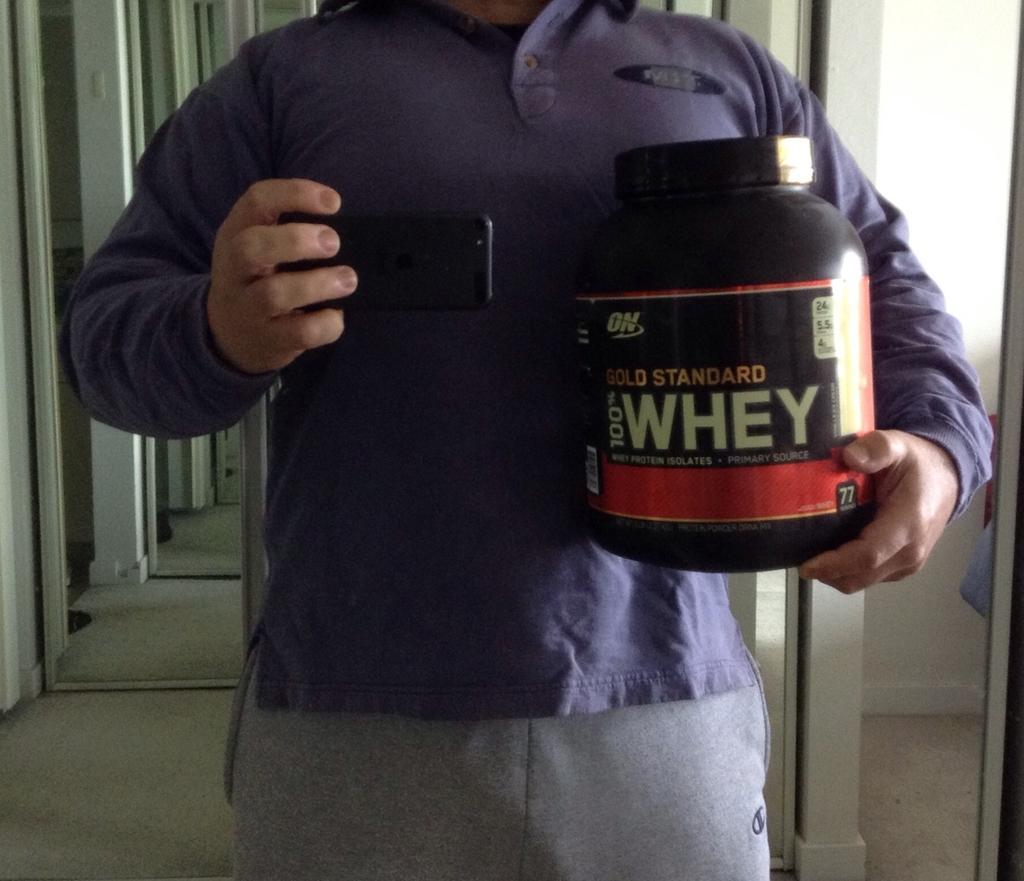Can you describe this image briefly? In this picture, we see a man in the blue T-shirt is holding a black color box in one of his hands and in the other hand, he is holding a mobile phone. I think he is clicking photos with the mobile phone. Behind him, we see the poles and a wall in white color. 